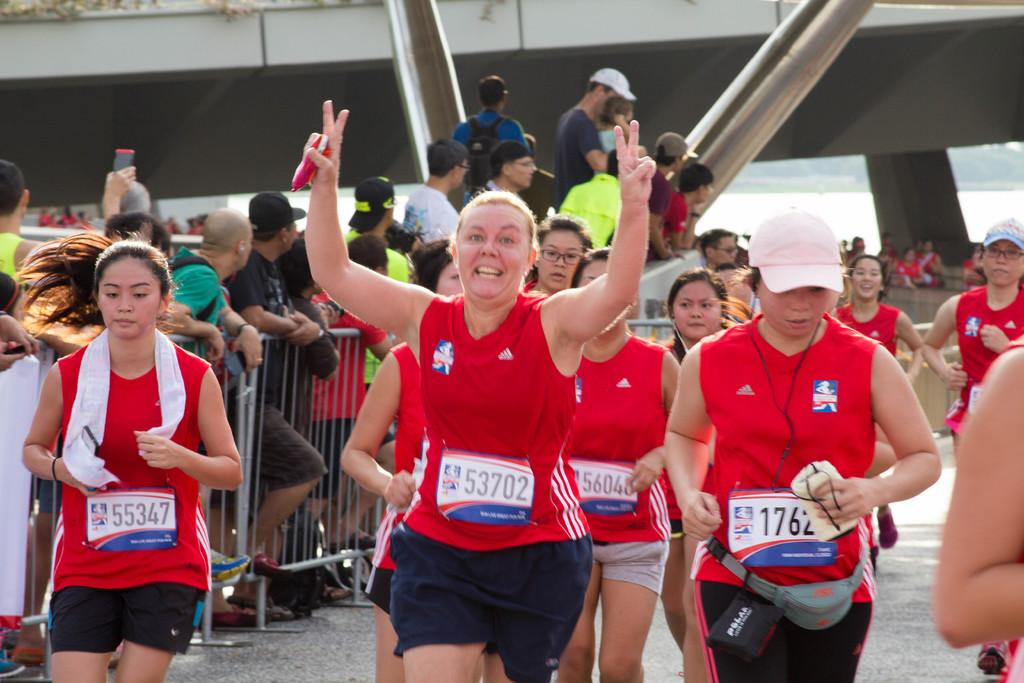What are the people wearing in the image? The people in the image are wearing red color shirts. What are the people in the foreground doing? The people in the foreground are running. What can be seen in the background of the image? In the background of the image, there is a group of people standing, trees, water, iron grills, and a building. What is the opinion of the trees about the flavor of the linen in the image? There are no trees or linen present in the image, and therefore no such interaction or opinion can be observed. 